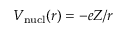Convert formula to latex. <formula><loc_0><loc_0><loc_500><loc_500>V _ { n u c l } ( r ) = - e Z / r</formula> 